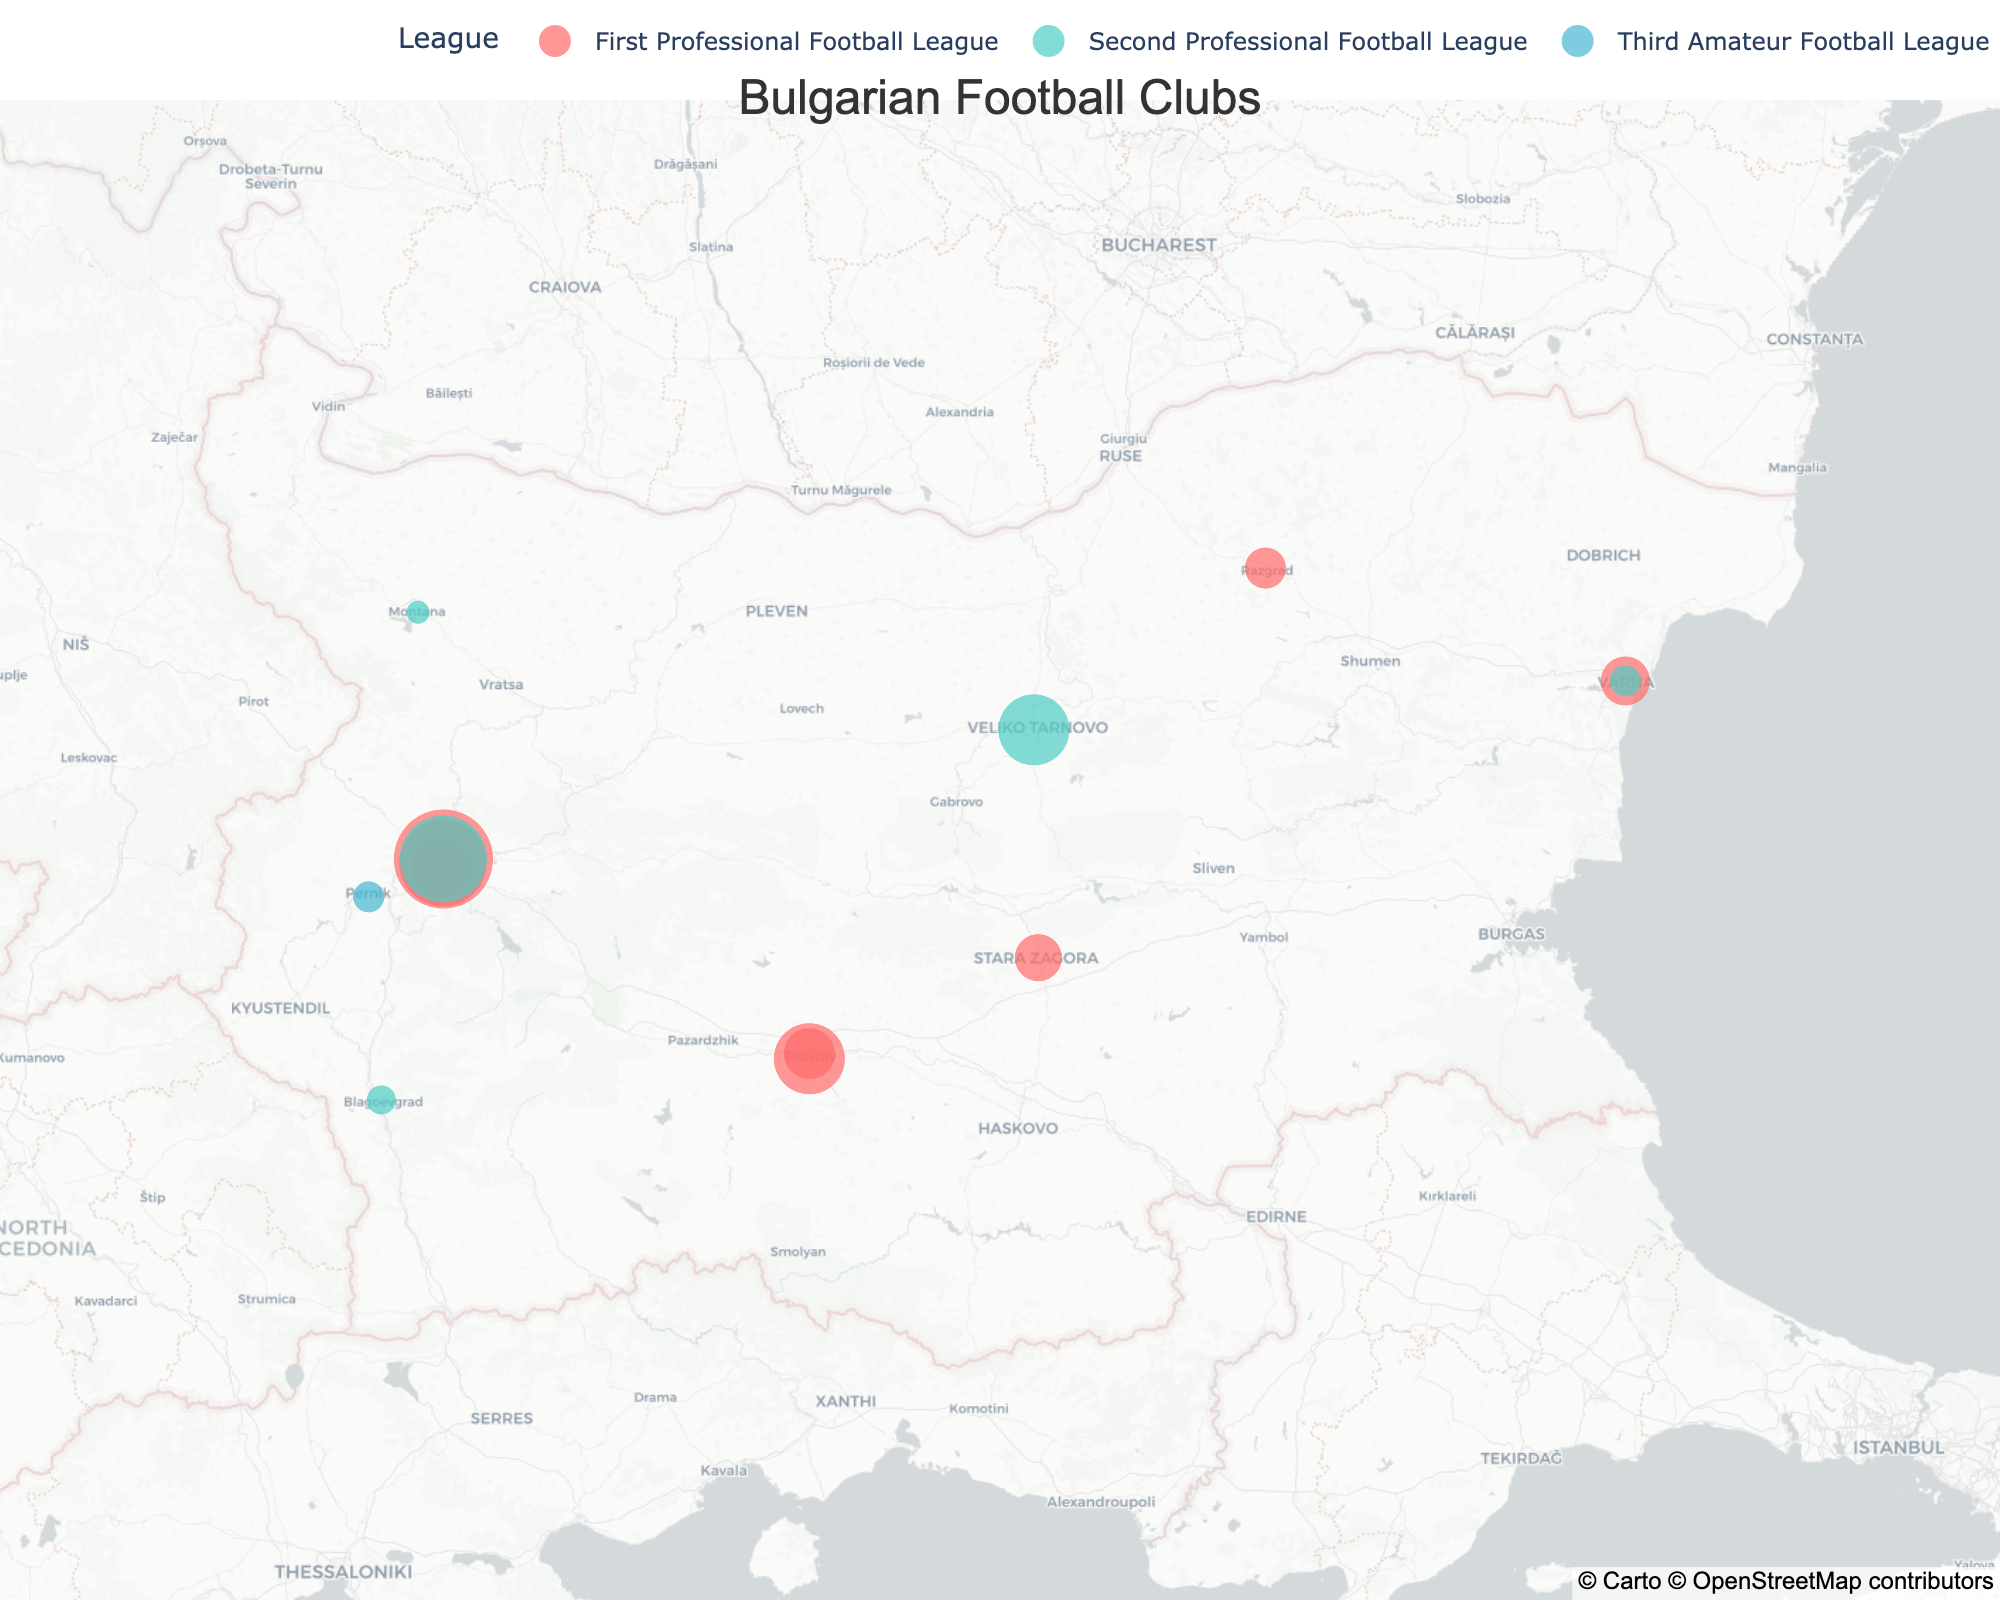Which city has the most football clubs represented on the map? To determine which city has the most football clubs, observe the club distribution on the map. Sofia has four clubs: Levski Sofia, CSKA Sofia, Slavia Sofia, and Lokomotiv Sofia.
Answer: Sofia What is the stadium capacity of the largest stadium represented in the First Professional Football League? To find the largest stadium capacity in the First Professional Football League, look at the club with the largest marker size in that league. Levski Sofia's stadium has a capacity of 25,000.
Answer: 25,000 Which league has the club with the smallest stadium capacity? Compare the smallest marker sizes among the represented leagues. Montana in the Second Professional Football League has the smallest stadium capacity of 6,000.
Answer: Second Professional Football League What is the total stadium capacity for all clubs in Sofia? Sum the stadium capacities of all clubs in Sofia: Levski Sofia (25,000), CSKA Sofia (22,000), Slavia Sofia (15,000), and Lokomotiv Sofia (22,000). Calculations: 25,000 + 22,000 + 15,000 + 22,000 = 84,000.
Answer: 84,000 How many clubs from the Second Professional Football League are shown on the map? Count the number of clubs listed under the Second Professional Football League: Etar Veliko Tarnovo, Montana, Spartak Varna, Lokomotiv Sofia, Pirin Blagoevgrad.
Answer: 5 Which city has the highest total stadium capacity, disregarding leagues? Sum the stadium capacity of clubs in each city and compare. Sofia has Levski (25,000), CSKA (22,000), Lokomotiv (22,000), and Slavia (15,000), giving a total of 84,000. No other city has a higher combined capacity.
Answer: Sofia Is Ludogorets Razgrad's stadium capacity larger or smaller than Beroe Stara Zagora's? Compare the two capacities: Ludogorets Razgrad’s stadium has 10,500 capacity, while Beroe Stara Zagora’s stadium has 12,000 capacity. Ludogorets Razgrad's capacity is smaller.
Answer: Smaller Which club represents Blagoevgrad, and what is its league? Check the map for Blagoevgrad and identify the club listed there. Pirin Blagoevgrad represents this city, and it is in the Second Professional Football League.
Answer: Pirin Blagoevgrad, Second Professional Football League What is the average stadium capacity for clubs in Varna? Calculate the average capacity for Cherno More Varna (12,500) and Spartak Varna (8,000). Sum: 12,500 + 8,000 = 20,500. Average: 20,500 / 2 = 10,250.
Answer: 10,250 Which clubs are in Plovdiv and what is their league level? Identify the clubs located in Plovdiv and list their leagues. Botev Plovdiv and Lokomotiv Plovdiv are in the First Professional Football League.
Answer: Botev Plovdiv, Lokomotiv Plovdiv; First Professional Football League 